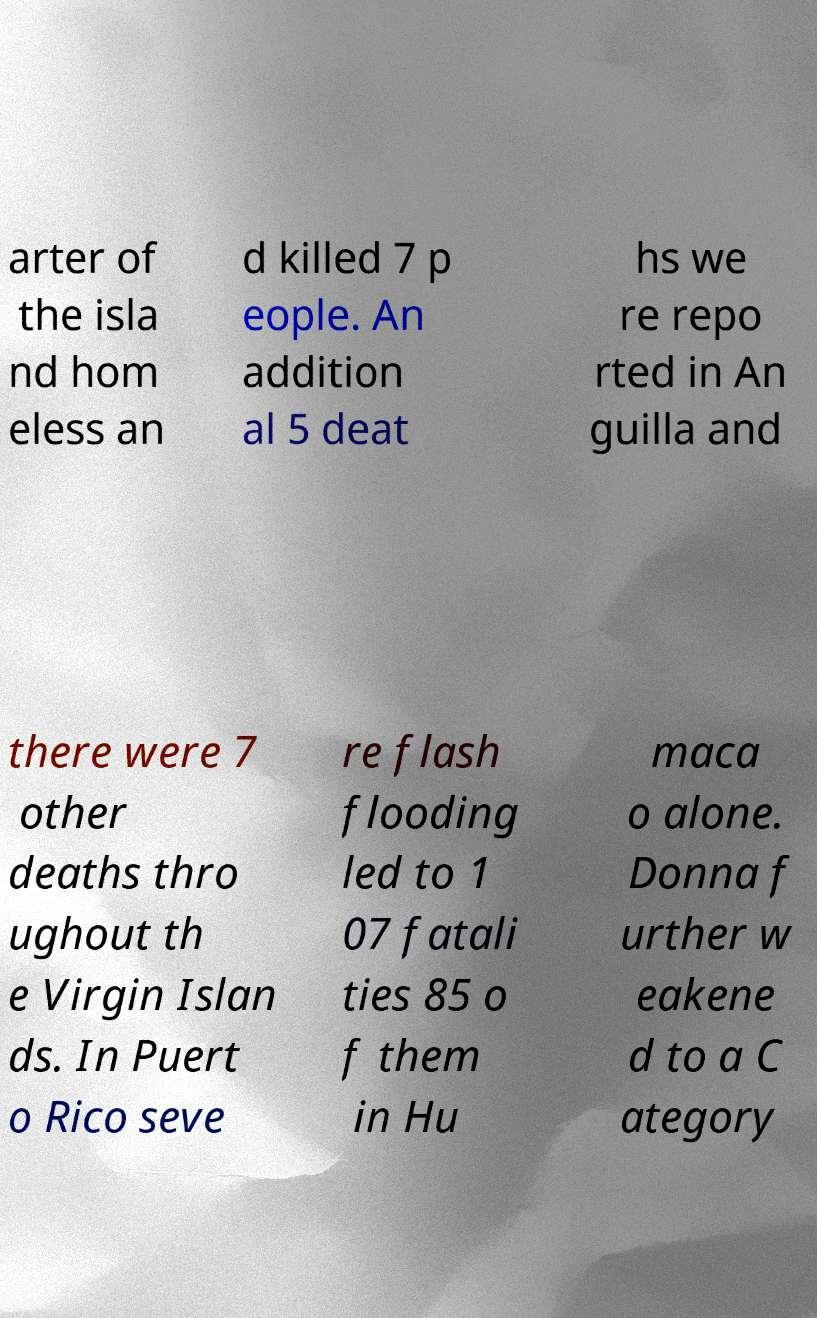What messages or text are displayed in this image? I need them in a readable, typed format. arter of the isla nd hom eless an d killed 7 p eople. An addition al 5 deat hs we re repo rted in An guilla and there were 7 other deaths thro ughout th e Virgin Islan ds. In Puert o Rico seve re flash flooding led to 1 07 fatali ties 85 o f them in Hu maca o alone. Donna f urther w eakene d to a C ategory 